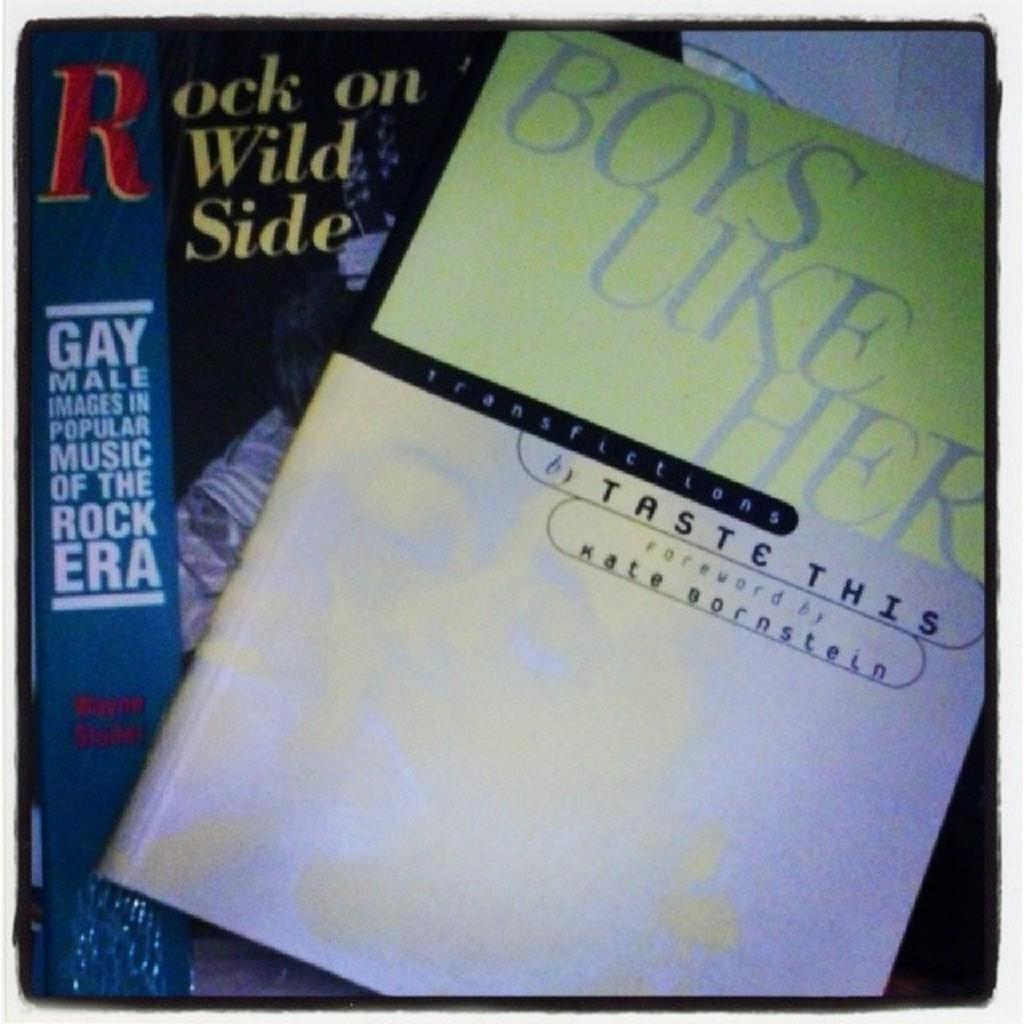<image>
Provide a brief description of the given image. A book called Boys Like Her is laying on top of another one titled Rock on Wild Side. 